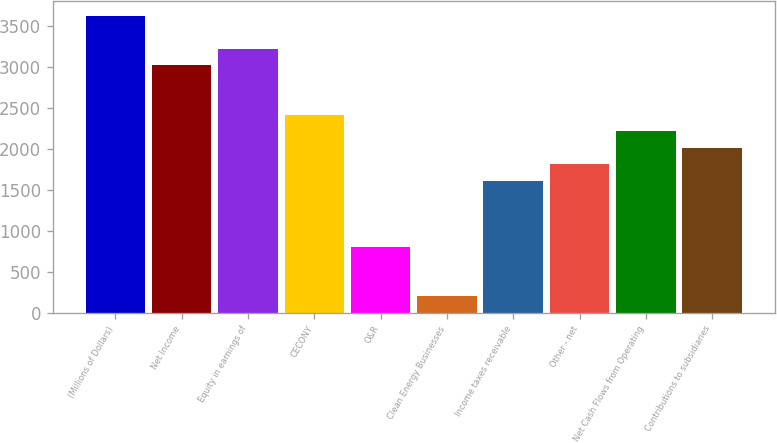Convert chart to OTSL. <chart><loc_0><loc_0><loc_500><loc_500><bar_chart><fcel>(Millions of Dollars)<fcel>Net Income<fcel>Equity in earnings of<fcel>CECONY<fcel>O&R<fcel>Clean Energy Businesses<fcel>Income taxes receivable<fcel>Other - net<fcel>Net Cash Flows from Operating<fcel>Contributions to subsidiaries<nl><fcel>3627.2<fcel>3023<fcel>3224.4<fcel>2418.8<fcel>807.6<fcel>203.4<fcel>1613.2<fcel>1814.6<fcel>2217.4<fcel>2016<nl></chart> 